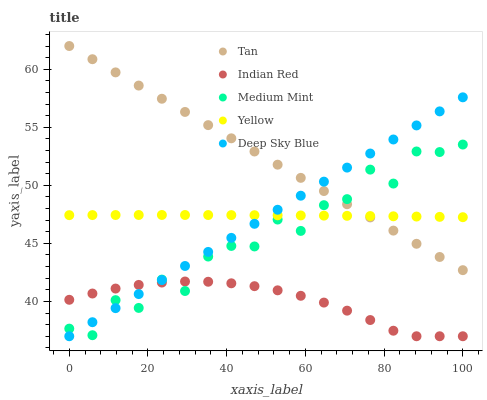Does Indian Red have the minimum area under the curve?
Answer yes or no. Yes. Does Tan have the maximum area under the curve?
Answer yes or no. Yes. Does Deep Sky Blue have the minimum area under the curve?
Answer yes or no. No. Does Deep Sky Blue have the maximum area under the curve?
Answer yes or no. No. Is Tan the smoothest?
Answer yes or no. Yes. Is Medium Mint the roughest?
Answer yes or no. Yes. Is Deep Sky Blue the smoothest?
Answer yes or no. No. Is Deep Sky Blue the roughest?
Answer yes or no. No. Does Deep Sky Blue have the lowest value?
Answer yes or no. Yes. Does Tan have the lowest value?
Answer yes or no. No. Does Tan have the highest value?
Answer yes or no. Yes. Does Deep Sky Blue have the highest value?
Answer yes or no. No. Is Indian Red less than Yellow?
Answer yes or no. Yes. Is Tan greater than Indian Red?
Answer yes or no. Yes. Does Tan intersect Medium Mint?
Answer yes or no. Yes. Is Tan less than Medium Mint?
Answer yes or no. No. Is Tan greater than Medium Mint?
Answer yes or no. No. Does Indian Red intersect Yellow?
Answer yes or no. No. 